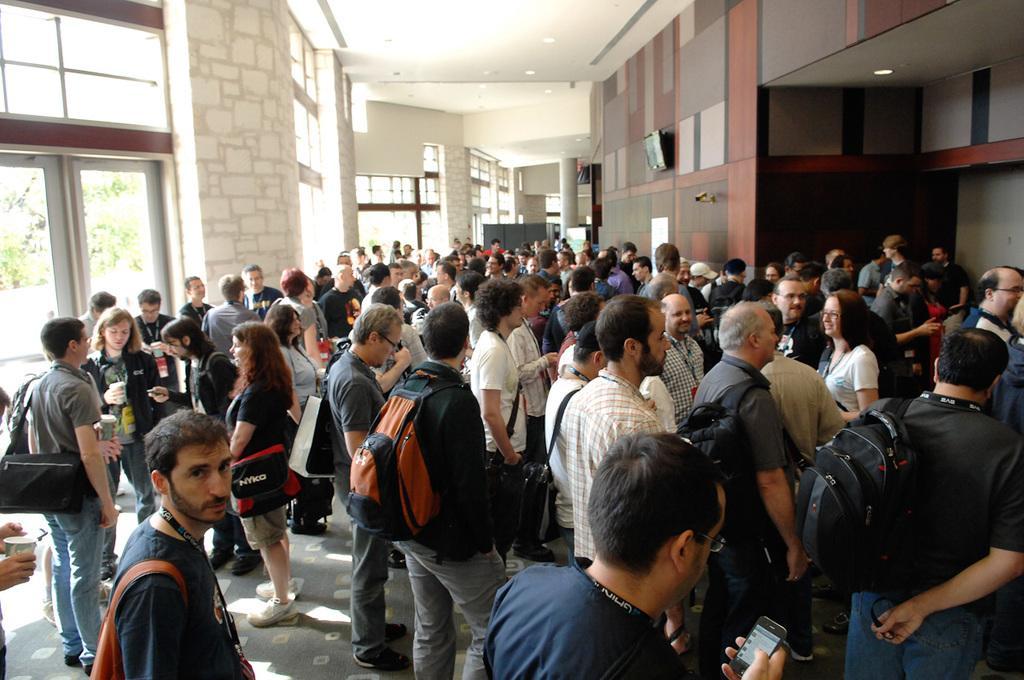Describe this image in one or two sentences. There is a crowd present as we can see at the bottom of this image and there is a wall in the background. We can see a glass door is on the left side of this image. 